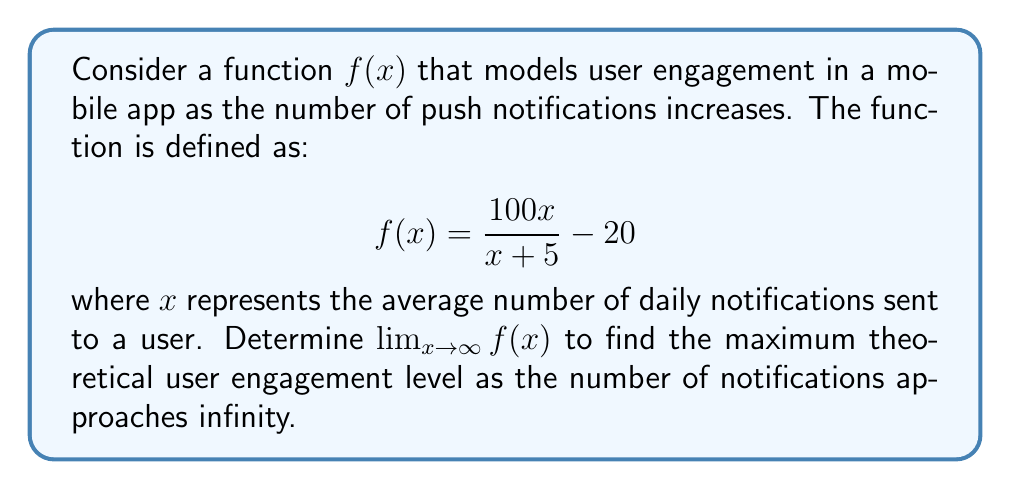Teach me how to tackle this problem. To find the limit of $f(x)$ as $x$ approaches infinity, we'll follow these steps:

1) First, let's examine the function:
   $$f(x) = \frac{100x}{x + 5} - 20$$

2) To find the limit as $x$ approaches infinity, we need to consider the behavior of each part of the function for very large values of $x$.

3) Let's focus on the fraction $\frac{100x}{x + 5}$:
   - As $x$ gets very large, the 5 in the denominator becomes negligible compared to $x$.
   - So, for very large $x$, this fraction behaves similarly to $\frac{100x}{x} = 100$.

4) We can formalize this intuition using the following steps:
   $$\lim_{x \to \infty} \frac{100x}{x + 5} = 100 \cdot \lim_{x \to \infty} \frac{x}{x + 5}$$
   
   $$= 100 \cdot \lim_{x \to \infty} \frac{1}{1 + \frac{5}{x}}$$
   
   $$= 100 \cdot \frac{1}{1 + 0} = 100$$

5) Now, considering the entire function:
   $$\lim_{x \to \infty} f(x) = \lim_{x \to \infty} (\frac{100x}{x + 5} - 20)$$
   
   $$= \lim_{x \to \infty} \frac{100x}{x + 5} - \lim_{x \to \infty} 20$$
   
   $$= 100 - 20 = 80$$

Thus, as the number of notifications approaches infinity, the user engagement level approaches a maximum of 80 units above the baseline.
Answer: $\lim_{x \to \infty} f(x) = 80$ 